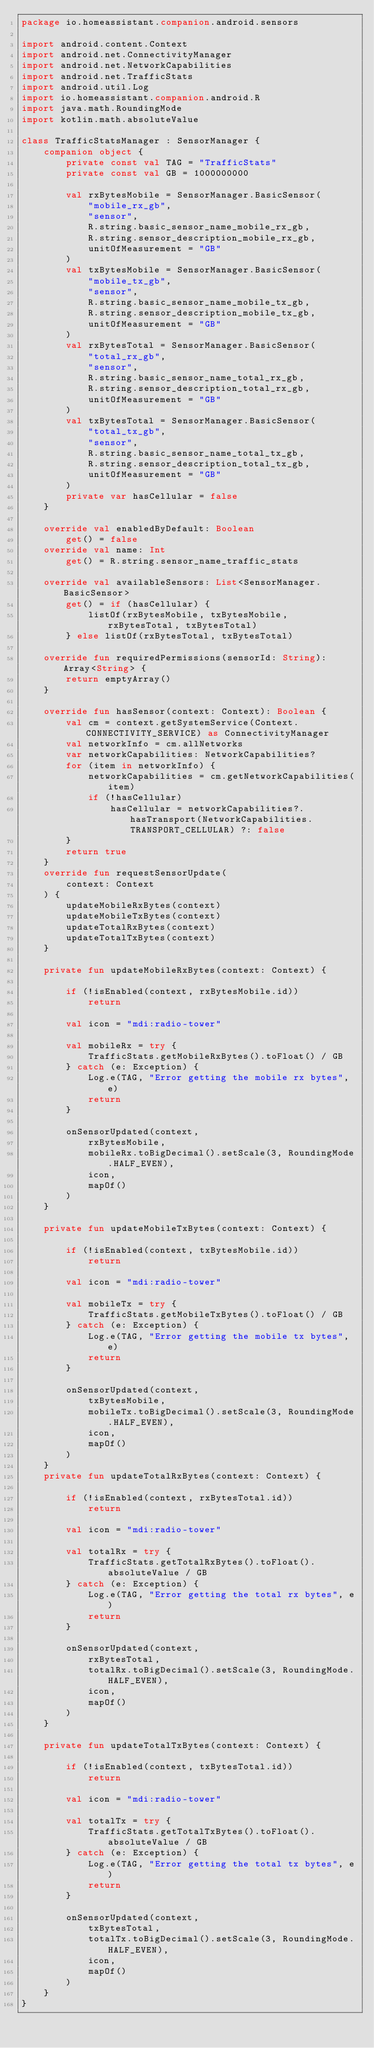<code> <loc_0><loc_0><loc_500><loc_500><_Kotlin_>package io.homeassistant.companion.android.sensors

import android.content.Context
import android.net.ConnectivityManager
import android.net.NetworkCapabilities
import android.net.TrafficStats
import android.util.Log
import io.homeassistant.companion.android.R
import java.math.RoundingMode
import kotlin.math.absoluteValue

class TrafficStatsManager : SensorManager {
    companion object {
        private const val TAG = "TrafficStats"
        private const val GB = 1000000000

        val rxBytesMobile = SensorManager.BasicSensor(
            "mobile_rx_gb",
            "sensor",
            R.string.basic_sensor_name_mobile_rx_gb,
            R.string.sensor_description_mobile_rx_gb,
            unitOfMeasurement = "GB"
        )
        val txBytesMobile = SensorManager.BasicSensor(
            "mobile_tx_gb",
            "sensor",
            R.string.basic_sensor_name_mobile_tx_gb,
            R.string.sensor_description_mobile_tx_gb,
            unitOfMeasurement = "GB"
        )
        val rxBytesTotal = SensorManager.BasicSensor(
            "total_rx_gb",
            "sensor",
            R.string.basic_sensor_name_total_rx_gb,
            R.string.sensor_description_total_rx_gb,
            unitOfMeasurement = "GB"
        )
        val txBytesTotal = SensorManager.BasicSensor(
            "total_tx_gb",
            "sensor",
            R.string.basic_sensor_name_total_tx_gb,
            R.string.sensor_description_total_tx_gb,
            unitOfMeasurement = "GB"
        )
        private var hasCellular = false
    }

    override val enabledByDefault: Boolean
        get() = false
    override val name: Int
        get() = R.string.sensor_name_traffic_stats

    override val availableSensors: List<SensorManager.BasicSensor>
        get() = if (hasCellular) {
            listOf(rxBytesMobile, txBytesMobile, rxBytesTotal, txBytesTotal)
        } else listOf(rxBytesTotal, txBytesTotal)

    override fun requiredPermissions(sensorId: String): Array<String> {
        return emptyArray()
    }

    override fun hasSensor(context: Context): Boolean {
        val cm = context.getSystemService(Context.CONNECTIVITY_SERVICE) as ConnectivityManager
        val networkInfo = cm.allNetworks
        var networkCapabilities: NetworkCapabilities?
        for (item in networkInfo) {
            networkCapabilities = cm.getNetworkCapabilities(item)
            if (!hasCellular)
                hasCellular = networkCapabilities?.hasTransport(NetworkCapabilities.TRANSPORT_CELLULAR) ?: false
        }
        return true
    }
    override fun requestSensorUpdate(
        context: Context
    ) {
        updateMobileRxBytes(context)
        updateMobileTxBytes(context)
        updateTotalRxBytes(context)
        updateTotalTxBytes(context)
    }

    private fun updateMobileRxBytes(context: Context) {

        if (!isEnabled(context, rxBytesMobile.id))
            return

        val icon = "mdi:radio-tower"

        val mobileRx = try {
            TrafficStats.getMobileRxBytes().toFloat() / GB
        } catch (e: Exception) {
            Log.e(TAG, "Error getting the mobile rx bytes", e)
            return
        }

        onSensorUpdated(context,
            rxBytesMobile,
            mobileRx.toBigDecimal().setScale(3, RoundingMode.HALF_EVEN),
            icon,
            mapOf()
        )
    }

    private fun updateMobileTxBytes(context: Context) {

        if (!isEnabled(context, txBytesMobile.id))
            return

        val icon = "mdi:radio-tower"

        val mobileTx = try {
            TrafficStats.getMobileTxBytes().toFloat() / GB
        } catch (e: Exception) {
            Log.e(TAG, "Error getting the mobile tx bytes", e)
            return
        }

        onSensorUpdated(context,
            txBytesMobile,
            mobileTx.toBigDecimal().setScale(3, RoundingMode.HALF_EVEN),
            icon,
            mapOf()
        )
    }
    private fun updateTotalRxBytes(context: Context) {

        if (!isEnabled(context, rxBytesTotal.id))
            return

        val icon = "mdi:radio-tower"

        val totalRx = try {
            TrafficStats.getTotalRxBytes().toFloat().absoluteValue / GB
        } catch (e: Exception) {
            Log.e(TAG, "Error getting the total rx bytes", e)
            return
        }

        onSensorUpdated(context,
            rxBytesTotal,
            totalRx.toBigDecimal().setScale(3, RoundingMode.HALF_EVEN),
            icon,
            mapOf()
        )
    }

    private fun updateTotalTxBytes(context: Context) {

        if (!isEnabled(context, txBytesTotal.id))
            return

        val icon = "mdi:radio-tower"

        val totalTx = try {
            TrafficStats.getTotalTxBytes().toFloat().absoluteValue / GB
        } catch (e: Exception) {
            Log.e(TAG, "Error getting the total tx bytes", e)
            return
        }

        onSensorUpdated(context,
            txBytesTotal,
            totalTx.toBigDecimal().setScale(3, RoundingMode.HALF_EVEN),
            icon,
            mapOf()
        )
    }
}
</code> 